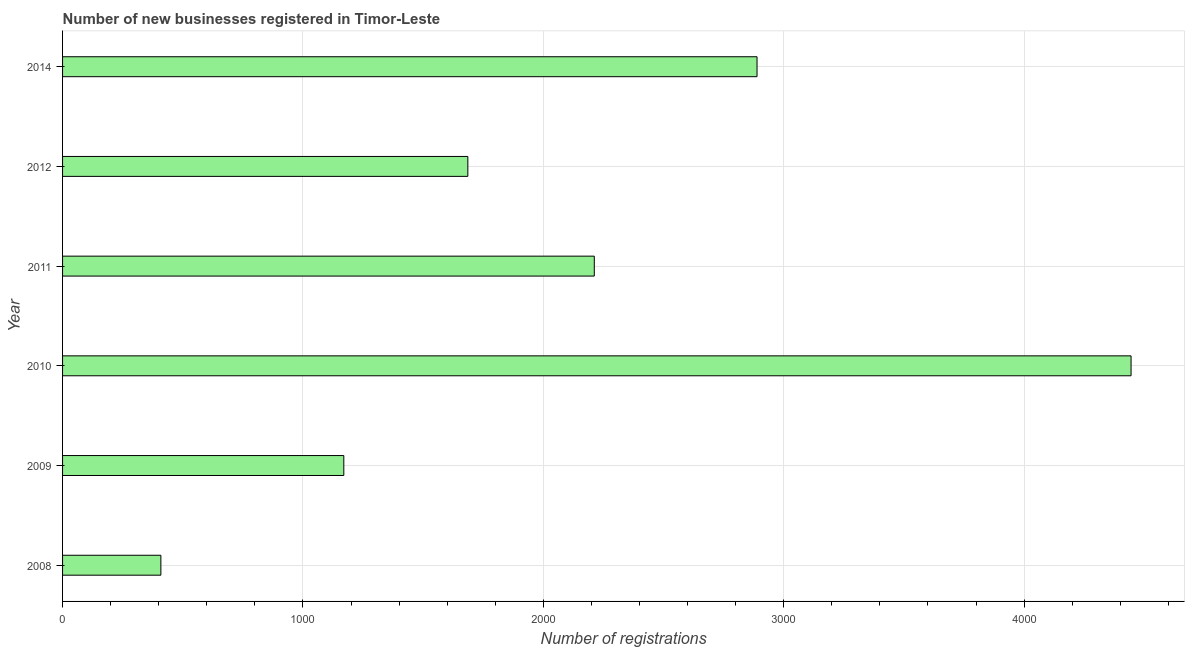What is the title of the graph?
Your response must be concise. Number of new businesses registered in Timor-Leste. What is the label or title of the X-axis?
Keep it short and to the point. Number of registrations. What is the label or title of the Y-axis?
Offer a very short reply. Year. What is the number of new business registrations in 2012?
Provide a succinct answer. 1686. Across all years, what is the maximum number of new business registrations?
Make the answer very short. 4445. Across all years, what is the minimum number of new business registrations?
Make the answer very short. 409. In which year was the number of new business registrations maximum?
Provide a short and direct response. 2010. In which year was the number of new business registrations minimum?
Offer a terse response. 2008. What is the sum of the number of new business registrations?
Your response must be concise. 1.28e+04. What is the difference between the number of new business registrations in 2010 and 2012?
Make the answer very short. 2759. What is the average number of new business registrations per year?
Make the answer very short. 2135. What is the median number of new business registrations?
Your answer should be very brief. 1949. In how many years, is the number of new business registrations greater than 1000 ?
Provide a succinct answer. 5. What is the ratio of the number of new business registrations in 2010 to that in 2014?
Your answer should be compact. 1.54. Is the number of new business registrations in 2009 less than that in 2011?
Give a very brief answer. Yes. What is the difference between the highest and the second highest number of new business registrations?
Your response must be concise. 1556. What is the difference between the highest and the lowest number of new business registrations?
Keep it short and to the point. 4036. In how many years, is the number of new business registrations greater than the average number of new business registrations taken over all years?
Your answer should be compact. 3. Are all the bars in the graph horizontal?
Your response must be concise. Yes. How many years are there in the graph?
Give a very brief answer. 6. Are the values on the major ticks of X-axis written in scientific E-notation?
Make the answer very short. No. What is the Number of registrations in 2008?
Your answer should be compact. 409. What is the Number of registrations in 2009?
Make the answer very short. 1170. What is the Number of registrations in 2010?
Provide a succinct answer. 4445. What is the Number of registrations in 2011?
Offer a very short reply. 2212. What is the Number of registrations of 2012?
Offer a very short reply. 1686. What is the Number of registrations of 2014?
Provide a short and direct response. 2889. What is the difference between the Number of registrations in 2008 and 2009?
Offer a very short reply. -761. What is the difference between the Number of registrations in 2008 and 2010?
Offer a very short reply. -4036. What is the difference between the Number of registrations in 2008 and 2011?
Your answer should be very brief. -1803. What is the difference between the Number of registrations in 2008 and 2012?
Ensure brevity in your answer.  -1277. What is the difference between the Number of registrations in 2008 and 2014?
Offer a very short reply. -2480. What is the difference between the Number of registrations in 2009 and 2010?
Offer a terse response. -3275. What is the difference between the Number of registrations in 2009 and 2011?
Ensure brevity in your answer.  -1042. What is the difference between the Number of registrations in 2009 and 2012?
Provide a short and direct response. -516. What is the difference between the Number of registrations in 2009 and 2014?
Your response must be concise. -1719. What is the difference between the Number of registrations in 2010 and 2011?
Keep it short and to the point. 2233. What is the difference between the Number of registrations in 2010 and 2012?
Offer a very short reply. 2759. What is the difference between the Number of registrations in 2010 and 2014?
Give a very brief answer. 1556. What is the difference between the Number of registrations in 2011 and 2012?
Provide a succinct answer. 526. What is the difference between the Number of registrations in 2011 and 2014?
Make the answer very short. -677. What is the difference between the Number of registrations in 2012 and 2014?
Offer a very short reply. -1203. What is the ratio of the Number of registrations in 2008 to that in 2010?
Your answer should be very brief. 0.09. What is the ratio of the Number of registrations in 2008 to that in 2011?
Offer a terse response. 0.18. What is the ratio of the Number of registrations in 2008 to that in 2012?
Ensure brevity in your answer.  0.24. What is the ratio of the Number of registrations in 2008 to that in 2014?
Your answer should be very brief. 0.14. What is the ratio of the Number of registrations in 2009 to that in 2010?
Your answer should be very brief. 0.26. What is the ratio of the Number of registrations in 2009 to that in 2011?
Provide a succinct answer. 0.53. What is the ratio of the Number of registrations in 2009 to that in 2012?
Offer a very short reply. 0.69. What is the ratio of the Number of registrations in 2009 to that in 2014?
Keep it short and to the point. 0.41. What is the ratio of the Number of registrations in 2010 to that in 2011?
Your response must be concise. 2.01. What is the ratio of the Number of registrations in 2010 to that in 2012?
Your response must be concise. 2.64. What is the ratio of the Number of registrations in 2010 to that in 2014?
Give a very brief answer. 1.54. What is the ratio of the Number of registrations in 2011 to that in 2012?
Your response must be concise. 1.31. What is the ratio of the Number of registrations in 2011 to that in 2014?
Your response must be concise. 0.77. What is the ratio of the Number of registrations in 2012 to that in 2014?
Your response must be concise. 0.58. 